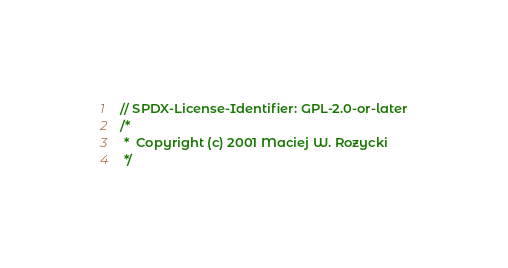<code> <loc_0><loc_0><loc_500><loc_500><_C_>// SPDX-License-Identifier: GPL-2.0-or-later
/*
 *	Copyright (c) 2001 Maciej W. Rozycki
 */
</code> 